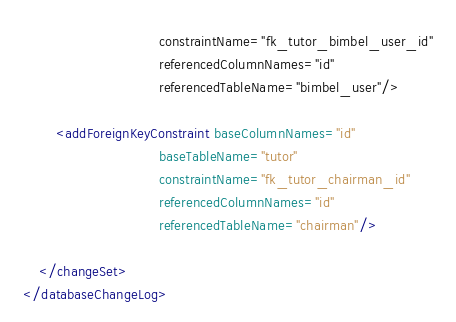Convert code to text. <code><loc_0><loc_0><loc_500><loc_500><_XML_>                                 constraintName="fk_tutor_bimbel_user_id"
                                 referencedColumnNames="id"
                                 referencedTableName="bimbel_user"/>

        <addForeignKeyConstraint baseColumnNames="id"
                                 baseTableName="tutor"
                                 constraintName="fk_tutor_chairman_id"
                                 referencedColumnNames="id"
                                 referencedTableName="chairman"/>

    </changeSet>
</databaseChangeLog>
</code> 